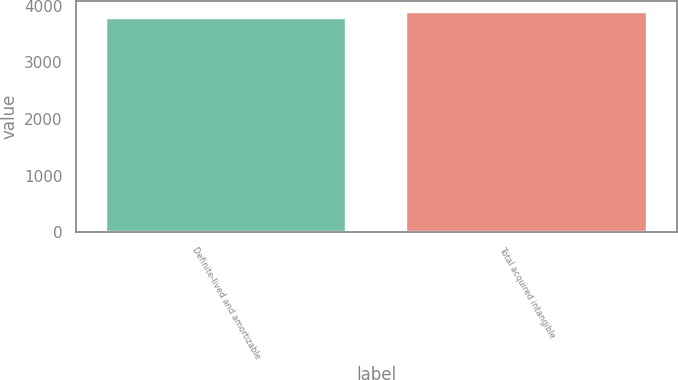Convert chart to OTSL. <chart><loc_0><loc_0><loc_500><loc_500><bar_chart><fcel>Definite-lived and amortizable<fcel>Total acquired intangible<nl><fcel>3793<fcel>3893<nl></chart> 